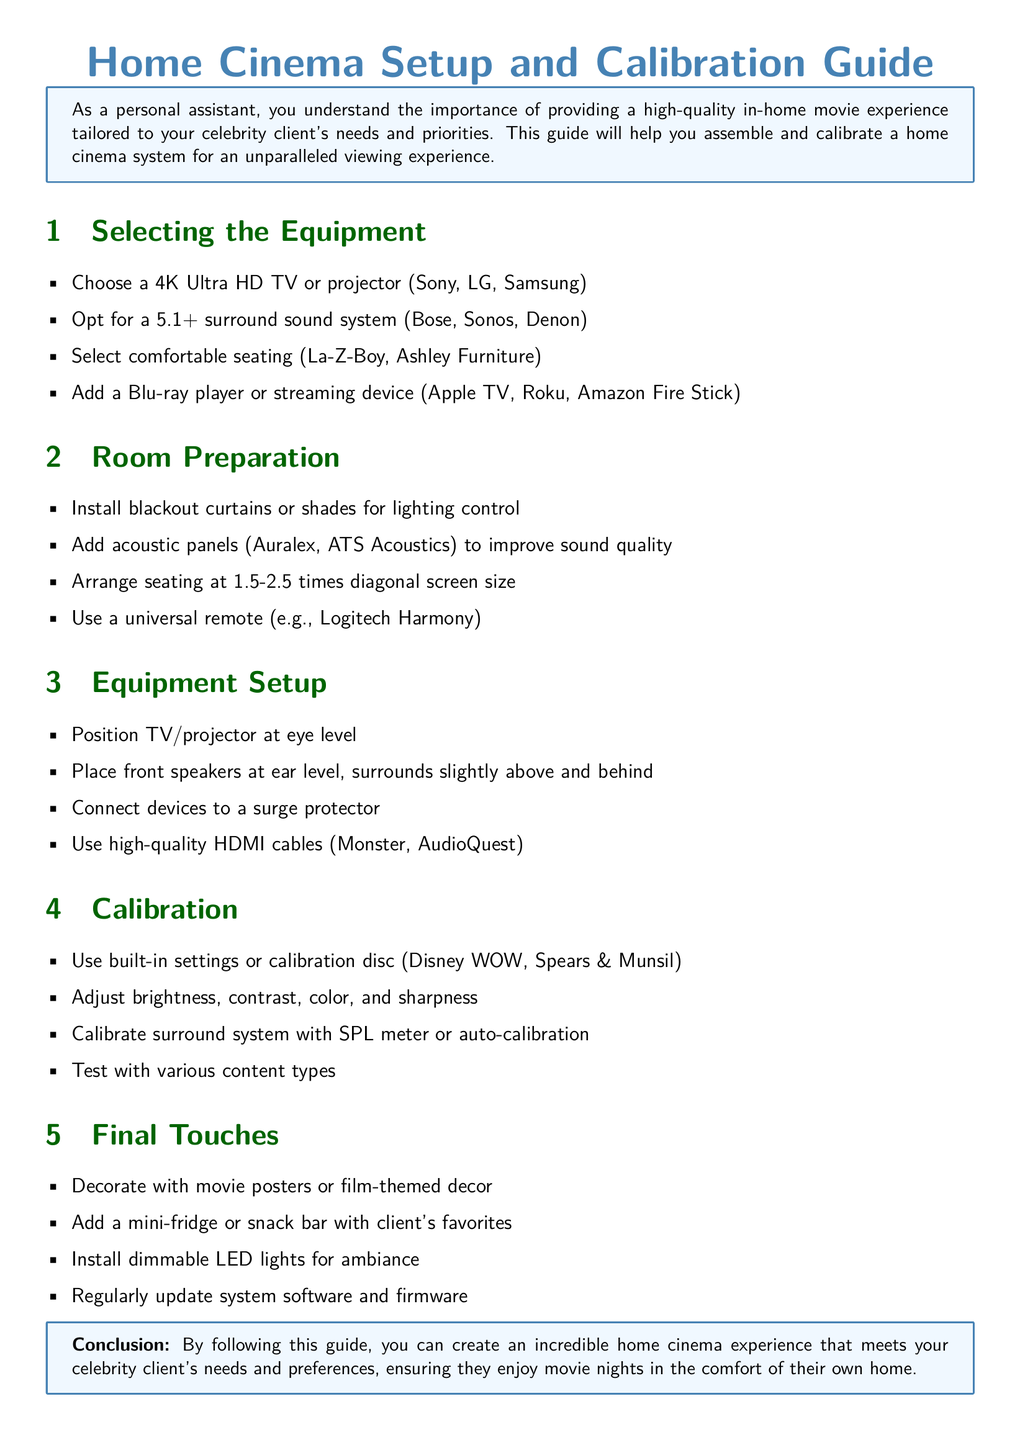What is the recommended screen type? The document suggests selecting a 4K Ultra HD TV or projector for optimal viewing.
Answer: 4K Ultra HD TV or projector Which audio system brands are mentioned? Bose, Sonos, and Denon are listed as options for surround sound systems.
Answer: Bose, Sonos, Denon What is the ideal seating arrangement distance? The document states that seating should be arranged at 1.5-2.5 times the diagonal screen size.
Answer: 1.5-2.5 times diagonal screen size What should you use for lighting control? The document recommends installing blackout curtains or shades.
Answer: Blackout curtains or shades Which device types should be connected to a surge protector? It is advised to connect all devices, including the TV and audio system, to a surge protector.
Answer: All devices How should you position the front speakers? Front speakers should be placed at ear level according to the setup instructions.
Answer: At ear level What is one way to enhance sound quality in the room? Adding acoustic panels is suggested to improve sound quality.
Answer: Acoustic panels Which calibration disc is mentioned? The document mentions using the Disney WOW calibration disc for settings adjustment.
Answer: Disney WOW What should be regular maintenance for the home cinema system? The document advises regularly updating system software and firmware.
Answer: Updating system software and firmware 